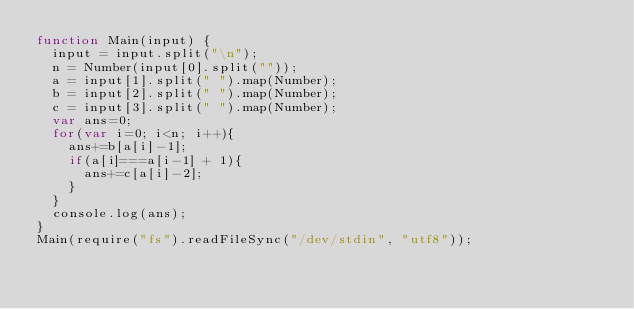Convert code to text. <code><loc_0><loc_0><loc_500><loc_500><_JavaScript_>function Main(input) {
  input = input.split("\n");
  n = Number(input[0].split(""));
  a = input[1].split(" ").map(Number);
  b = input[2].split(" ").map(Number);
  c = input[3].split(" ").map(Number);
  var ans=0;
  for(var i=0; i<n; i++){
    ans+=b[a[i]-1];
    if(a[i]===a[i-1] + 1){
      ans+=c[a[i]-2];
    }
  }
  console.log(ans);
}
Main(require("fs").readFileSync("/dev/stdin", "utf8"));</code> 